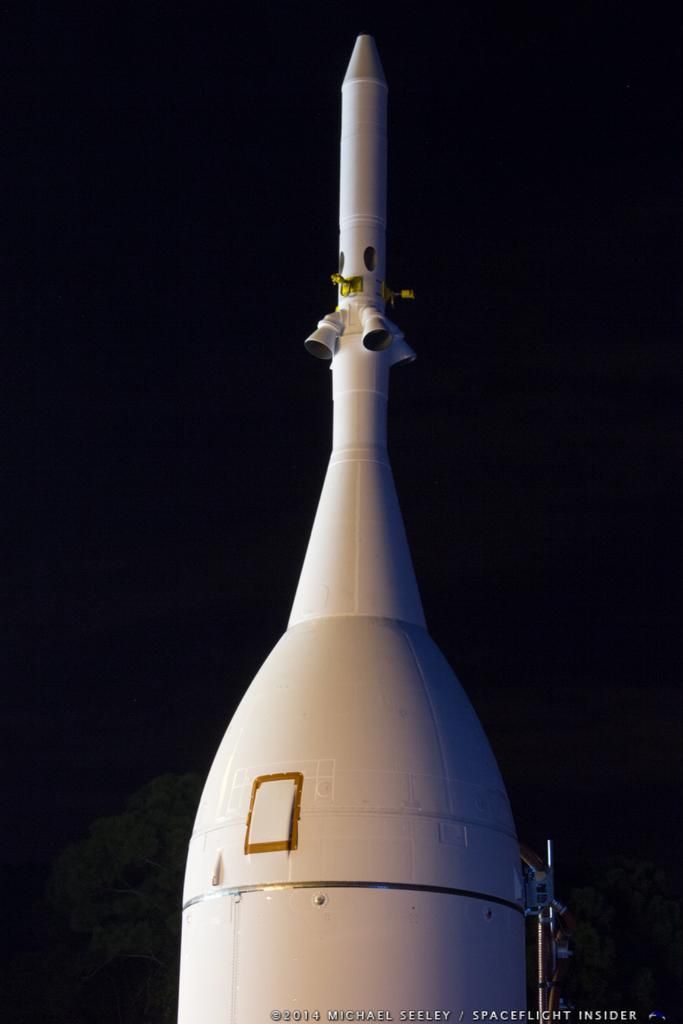What is the main subject of the image? The main subject of the image is a spacecraft launcher. What color is the spacecraft launcher? The spacecraft launcher is white in color. What can be seen in the background of the image? The background of the image is black. What type of bells can be heard ringing in the image? There are no bells present in the image, and therefore no sound can be heard. 